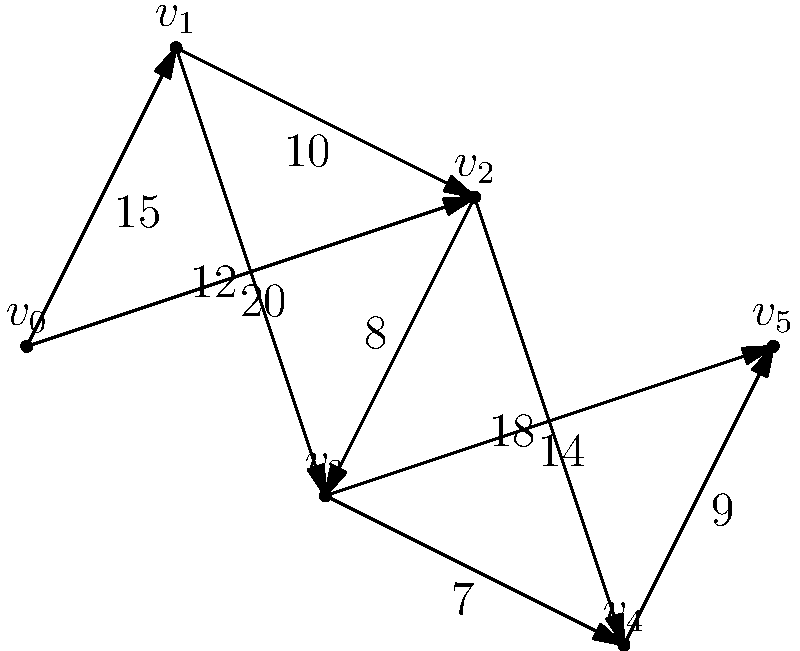In preparation for a crucial stage of a cycling race, you're analyzing the course represented by the graph above. The vertices represent key points along the route, and the edges represent road segments with their distances in kilometers. What is the shortest distance from the starting point $v_0$ to the finish line at $v_5$, and which path should you take to achieve this optimal route? To find the shortest path from $v_0$ to $v_5$, we'll use Dijkstra's algorithm:

1. Initialize:
   - Distance to $v_0$ = 0
   - Distance to all other vertices = $\infty$
   - Set of unvisited nodes = {$v_0$, $v_1$, $v_2$, $v_3$, $v_4$, $v_5$}

2. From $v_0$:
   - Update: $d(v_1) = 15$, $d(v_2) = 20$
   - Select $v_1$ (shortest distance)

3. From $v_1$:
   - Update: $d(v_2) = \min(20, 15+10) = 20$, $d(v_3) = 15+12 = 27$
   - Select $v_2$

4. From $v_2$:
   - Update: $d(v_3) = \min(27, 20+8) = 28$, $d(v_4) = 20+18 = 38$
   - Select $v_3$

5. From $v_3$:
   - Update: $d(v_4) = \min(38, 28+7) = 35$, $d(v_5) = 28+14 = 42$
   - Select $v_4$

6. From $v_4$:
   - Update: $d(v_5) = \min(42, 35+9) = 44$
   - Select $v_5$ (destination reached)

The shortest path is $v_0 \rightarrow v_1 \rightarrow v_2 \rightarrow v_3 \rightarrow v_4 \rightarrow v_5$ with a total distance of 44 km.
Answer: 44 km; Path: $v_0 \rightarrow v_1 \rightarrow v_2 \rightarrow v_3 \rightarrow v_4 \rightarrow v_5$ 